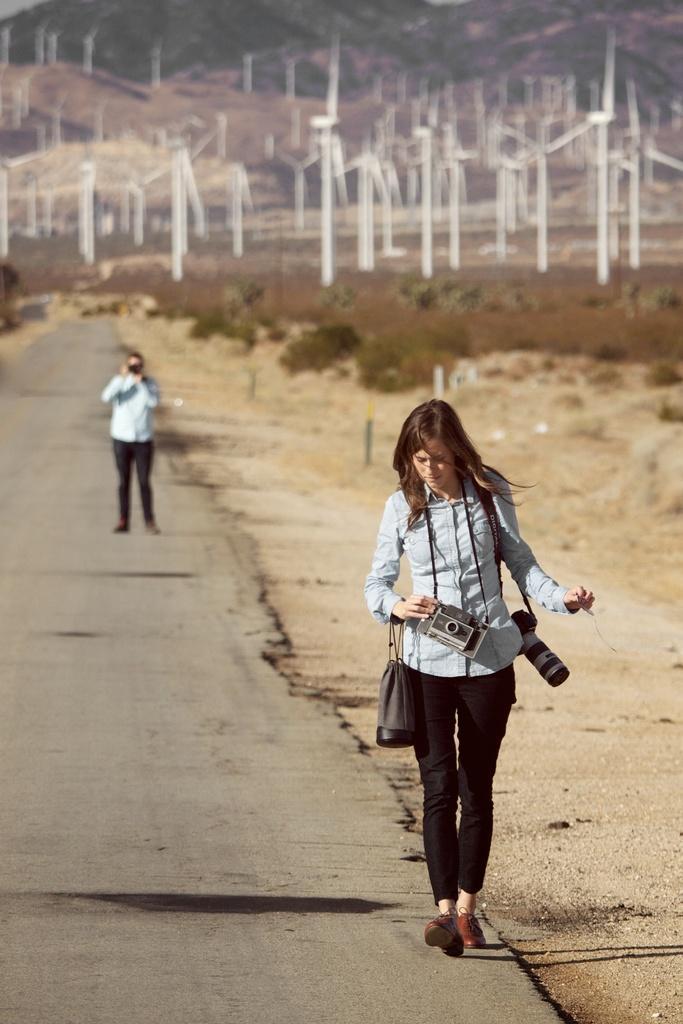Please provide a concise description of this image. In this image we can see this person wearing shirt is walking on road by holding cameras and bag. The background of the image is blurred, we can see a person standing on the road, we can see trees, wind turbines and the sky. 